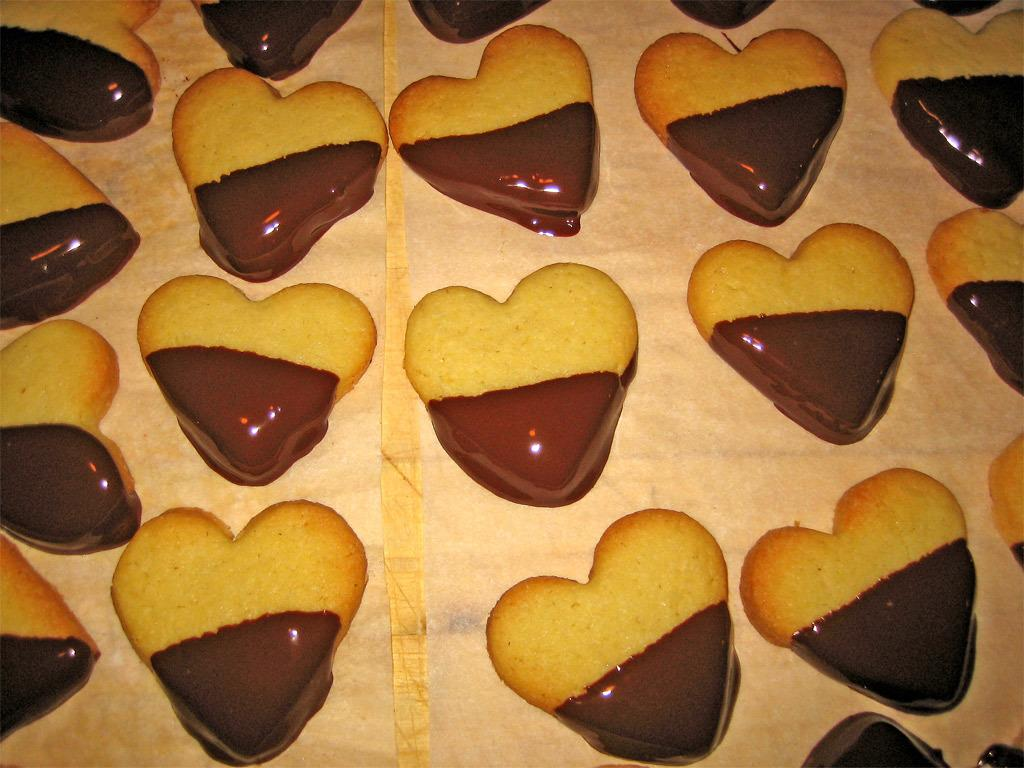What type of food is present in the image? There are cookies in the image. What shape are the cookies? The cookies are heart-shaped. What color are the cookies? The cookies are light brown in color. What is the additional topping on the cookies? There is chocolate on the cookies. Can you hear the kitten laughing while eating the gold-covered cookies in the image? There is no kitten or gold-covered cookies present in the image, and therefore no such activity can be observed. 